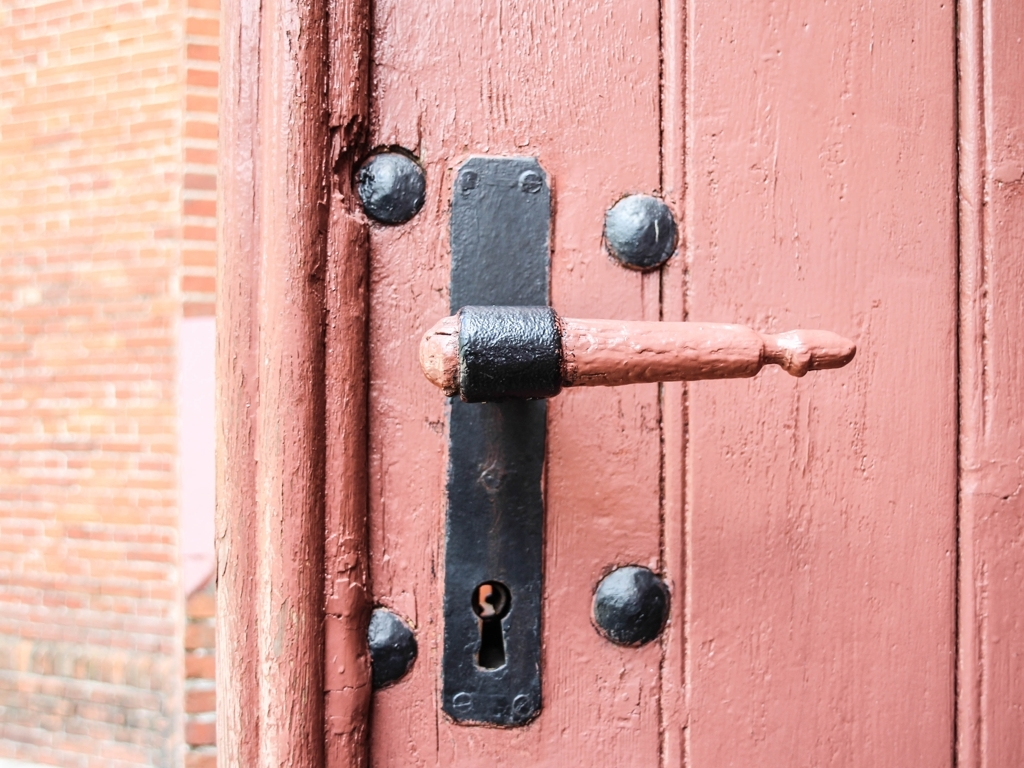What is the significance of the door handle design? The door handle shown in the image appears to be of a traditional design, likely serving both functional and aesthetic purposes. Its solid construction suggests durability, while the vintage style likely complements the historical architecture of the building. 